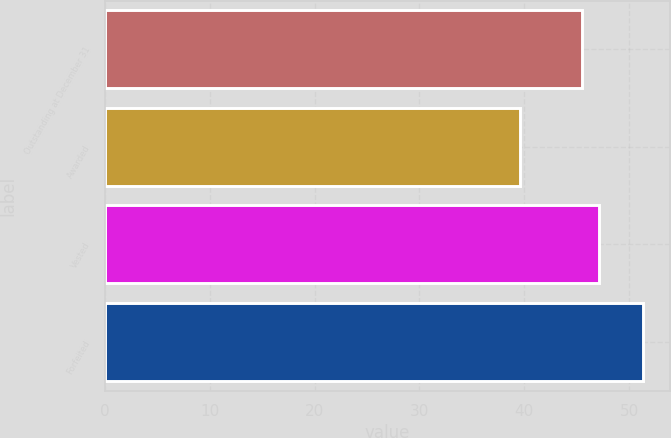Convert chart. <chart><loc_0><loc_0><loc_500><loc_500><bar_chart><fcel>Outstanding at December 31<fcel>Awarded<fcel>Vested<fcel>Forfeited<nl><fcel>45.55<fcel>39.57<fcel>47.16<fcel>51.36<nl></chart> 